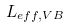<formula> <loc_0><loc_0><loc_500><loc_500>L _ { e f f , V B }</formula> 